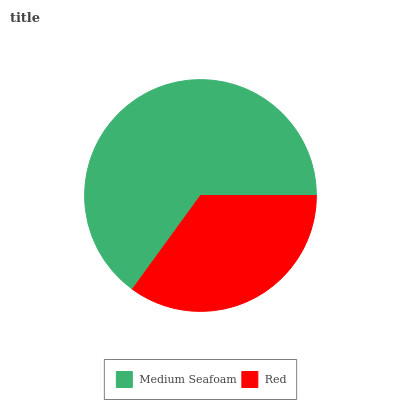Is Red the minimum?
Answer yes or no. Yes. Is Medium Seafoam the maximum?
Answer yes or no. Yes. Is Red the maximum?
Answer yes or no. No. Is Medium Seafoam greater than Red?
Answer yes or no. Yes. Is Red less than Medium Seafoam?
Answer yes or no. Yes. Is Red greater than Medium Seafoam?
Answer yes or no. No. Is Medium Seafoam less than Red?
Answer yes or no. No. Is Medium Seafoam the high median?
Answer yes or no. Yes. Is Red the low median?
Answer yes or no. Yes. Is Red the high median?
Answer yes or no. No. Is Medium Seafoam the low median?
Answer yes or no. No. 